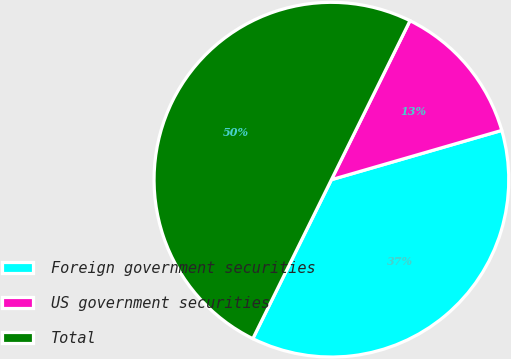<chart> <loc_0><loc_0><loc_500><loc_500><pie_chart><fcel>Foreign government securities<fcel>US government securities<fcel>Total<nl><fcel>36.79%<fcel>13.21%<fcel>50.0%<nl></chart> 